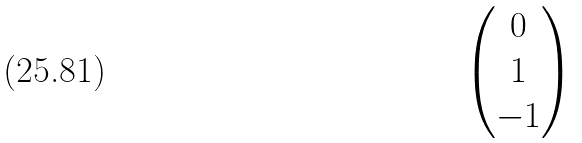<formula> <loc_0><loc_0><loc_500><loc_500>\begin{pmatrix} 0 \\ 1 \\ - 1 \\ \end{pmatrix}</formula> 